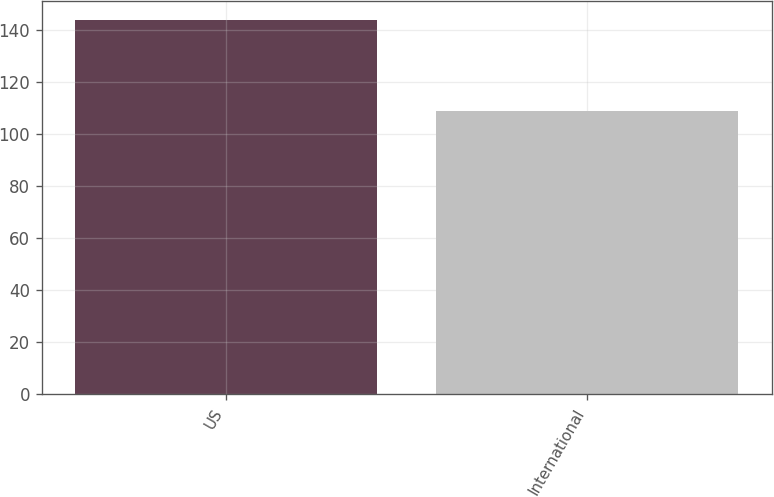<chart> <loc_0><loc_0><loc_500><loc_500><bar_chart><fcel>US<fcel>International<nl><fcel>144<fcel>109<nl></chart> 